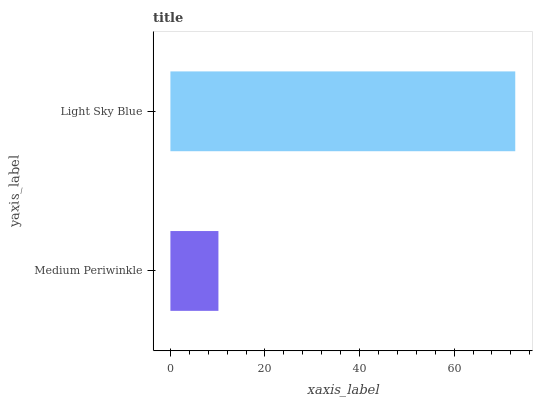Is Medium Periwinkle the minimum?
Answer yes or no. Yes. Is Light Sky Blue the maximum?
Answer yes or no. Yes. Is Light Sky Blue the minimum?
Answer yes or no. No. Is Light Sky Blue greater than Medium Periwinkle?
Answer yes or no. Yes. Is Medium Periwinkle less than Light Sky Blue?
Answer yes or no. Yes. Is Medium Periwinkle greater than Light Sky Blue?
Answer yes or no. No. Is Light Sky Blue less than Medium Periwinkle?
Answer yes or no. No. Is Light Sky Blue the high median?
Answer yes or no. Yes. Is Medium Periwinkle the low median?
Answer yes or no. Yes. Is Medium Periwinkle the high median?
Answer yes or no. No. Is Light Sky Blue the low median?
Answer yes or no. No. 